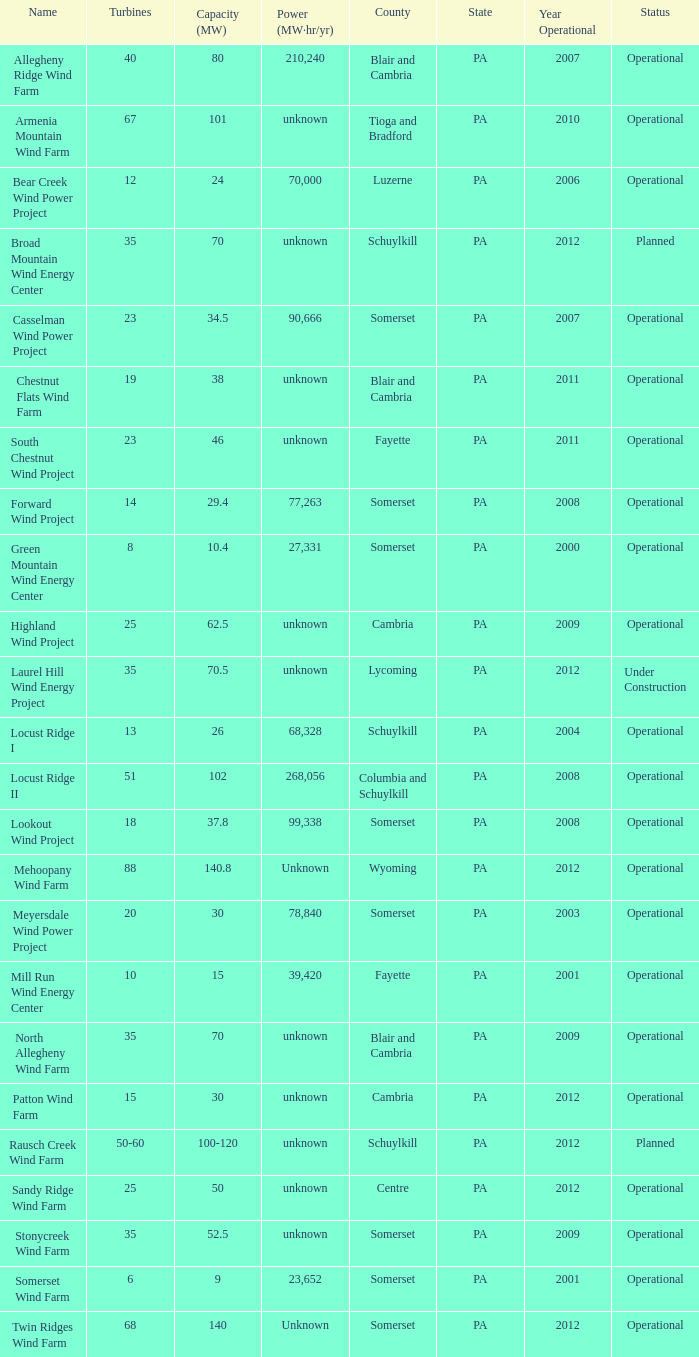In what year did fayette start operating at 46? 2011.0. 